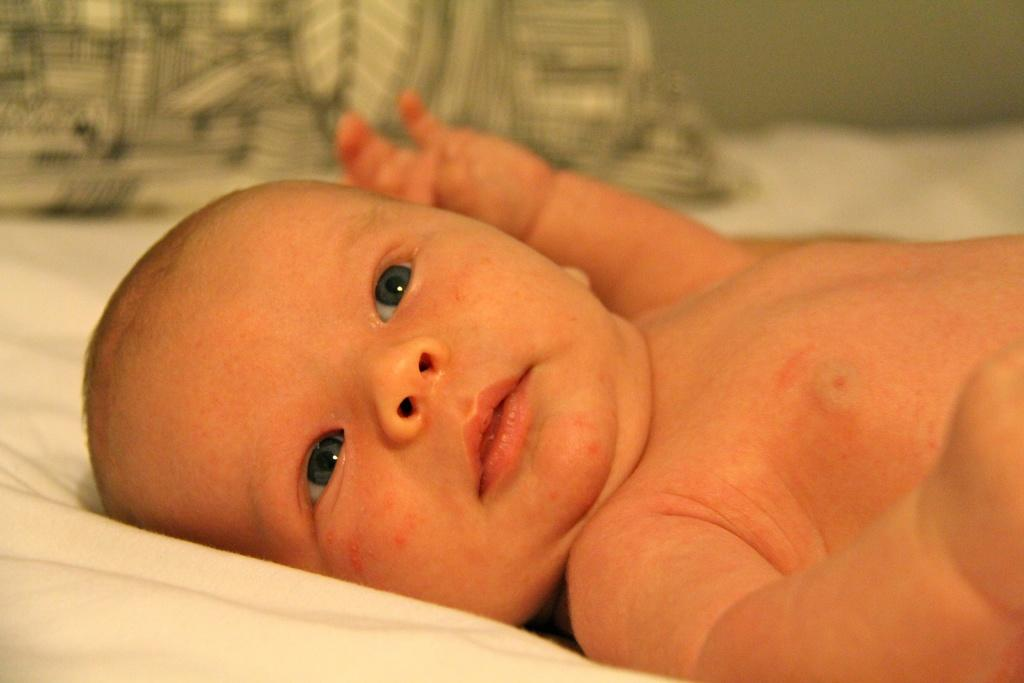What is the main subject of the image? There is a small baby in the image. What is the baby doing in the image? The baby is sleeping on the bed. Is the baby wearing any clothes in the image? No, the baby is not wearing clothes in the image. What can be seen at the top of the bed? There is a pillow at the top of the bed. What type of design is featured on the baby's shirt in the image? There is no shirt present in the image, as the baby is not wearing clothes. What role does the baby play in the ongoing war in the image? There is no war present in the image, and the baby is simply sleeping on the bed. 